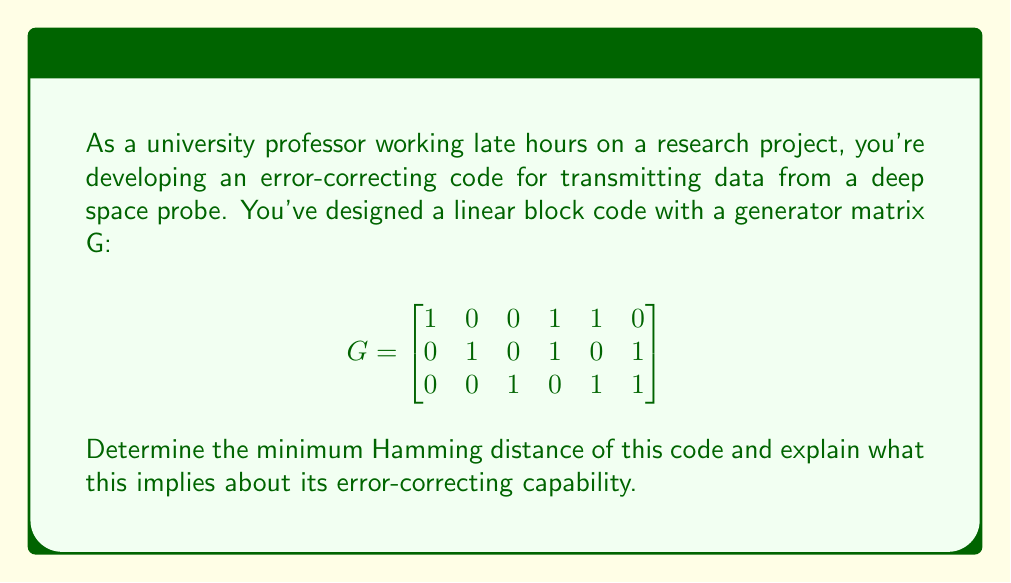Could you help me with this problem? To evaluate the error-correcting capability of this linear block code, we need to find its minimum Hamming distance. Let's approach this step-by-step:

1) First, we need to generate all possible codewords. Since this is a $(6,3)$ code (6 bits output, 3 bits input), we have $2^3 = 8$ possible codewords.

2) To generate the codewords, we multiply each possible 3-bit input vector by the generator matrix G:

   $$(000)G, (001)G, (010)G, (011)G, (100)G, (101)G, (110)G, (111)G$$

3) This gives us the following codewords:
   $$(000000), (001011), (010101), (011110), (100110), (101101), (110011), (111000)$$

4) The Hamming distance between two codewords is the number of positions in which they differ. The minimum Hamming distance ($d_{min}$) is the smallest distance between any pair of distinct codewords.

5) Comparing each codeword with every other codeword, we find that the minimum Hamming distance is 3.

6) For a linear code, the minimum Hamming distance is equal to the minimum weight (number of 1's) of any non-zero codeword. We can verify this by checking the weights of all non-zero codewords, which are indeed all 3 or more.

7) The error-correcting capability of a code is related to its minimum Hamming distance. A code with minimum distance $d_{min}$ can:
   - Detect up to $d_{min} - 1$ errors
   - Correct up to $\lfloor \frac{d_{min} - 1}{2} \rfloor$ errors

8) In this case, with $d_{min} = 3$, the code can:
   - Detect up to 2 errors
   - Correct up to $\lfloor \frac{3 - 1}{2} \rfloor = 1$ error

This means that in your deep space communication system, this code can correct any single-bit error in each transmitted codeword, ensuring more reliable data transmission despite potential interference or noise in the communication channel.
Answer: The minimum Hamming distance of the code is 3. This implies that the code can detect up to 2 errors and correct up to 1 error in each transmitted codeword. 